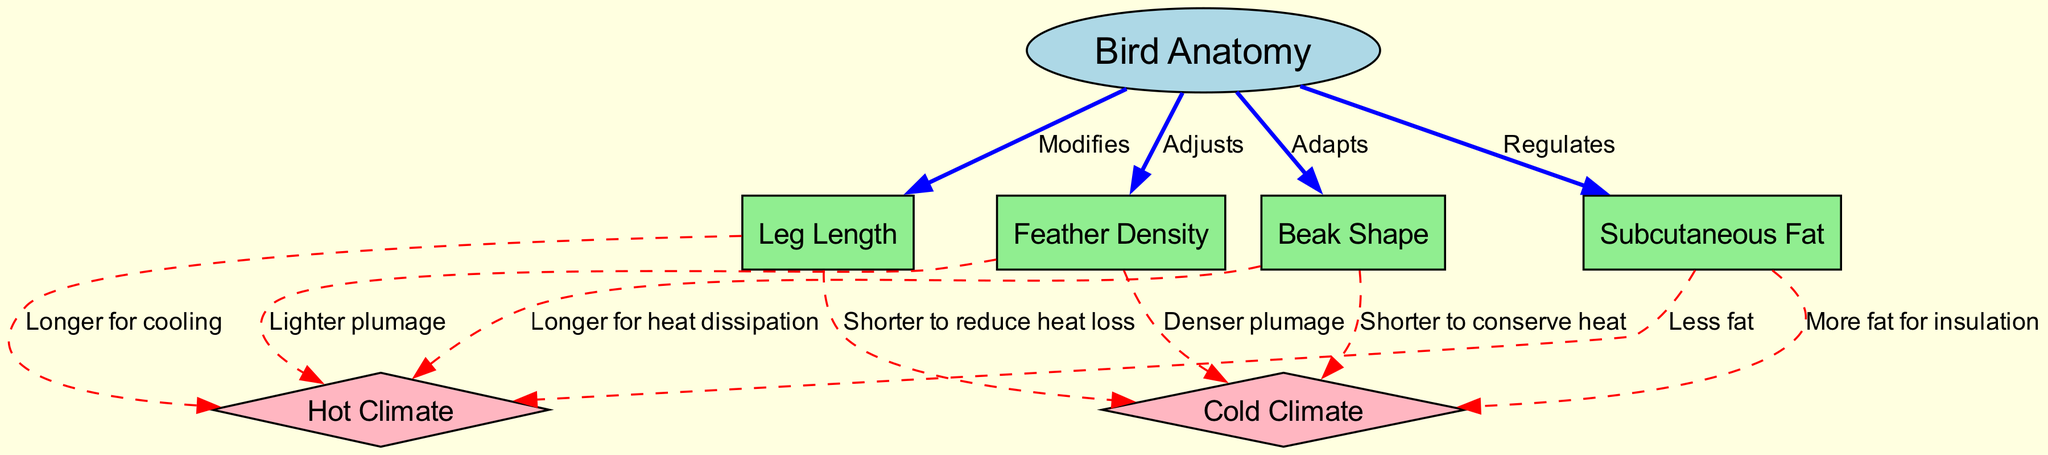What are the two types of climates represented in the diagram? The diagram includes two climate types, which are distinctly labeled as "Hot Climate" and "Cold Climate." These climate nodes are color-coded as diamonds, indicating their significance in the context of bird anatomical adaptations.
Answer: Hot Climate, Cold Climate How many nodes are present in the diagram? The total count of nodes is determined by looking at each unique label in the diagram. There are six nodes: Bird Anatomy, Beak Shape, Feather Density, Leg Length, Subcutaneous Fat, Hot Climate, and Cold Climate. This sums up to six nodes.
Answer: 6 What adaptation is described for beak shape in hot climates? The adaptation related to beak shape in hot climates is specified as "Longer for heat dissipation." This relationship is indicated by a dashed red edge connecting Beak Shape to Hot Climate, further clarifying the specific adaptation.
Answer: Longer for heat dissipation What adaptation is indicated for legs in cold climates? In the diagram, the adaptation for legs in cold climates is conveyed as "Shorter to reduce heat loss." This is depicted through a specific directional edge from Legs to Cold Climate, highlighting this unique adaptation mechanism.
Answer: Shorter to reduce heat loss Which feature is adjusted for feather density in hot climates? The diagram illustrates that for feather density in hot climates, the adaptation is described as "Lighter plumage." A dashed red edge connects Feather Density to Hot Climate, indicating this adjustment in response to environmental conditions.
Answer: Lighter plumage Which anatomical feature regulates the amount of fat in cold climates? The diagram states that Subcutaneous Fat is regulated in cold climates as "More fat for insulation." This regulation is represented by an edge pointing from Fat to Cold Climate, showcasing how birds adapt to retain warmth through fat.
Answer: More fat for insulation What does the diagram suggest about leg length in hot climates? The adaptation for leg length in hot climates is indicated as "Longer for cooling." This relationship is visually represented through an edge from Legs to Hot Climate, describing how longer legs help in cooling the bird's body.
Answer: Longer for cooling What does the 'regulates' label imply about the relationship between bird anatomy and fat in the context of climate adaptation? The term 'regulates' indicates that the amount of fat in birds is directly controlled based on climate conditions. Specifically, the diagram shows that birds will decrease their fat for survival in hot climates and increase it for insulation in cold climates, demonstrating adaptive behavior.
Answer: Direct control based on climate conditions 